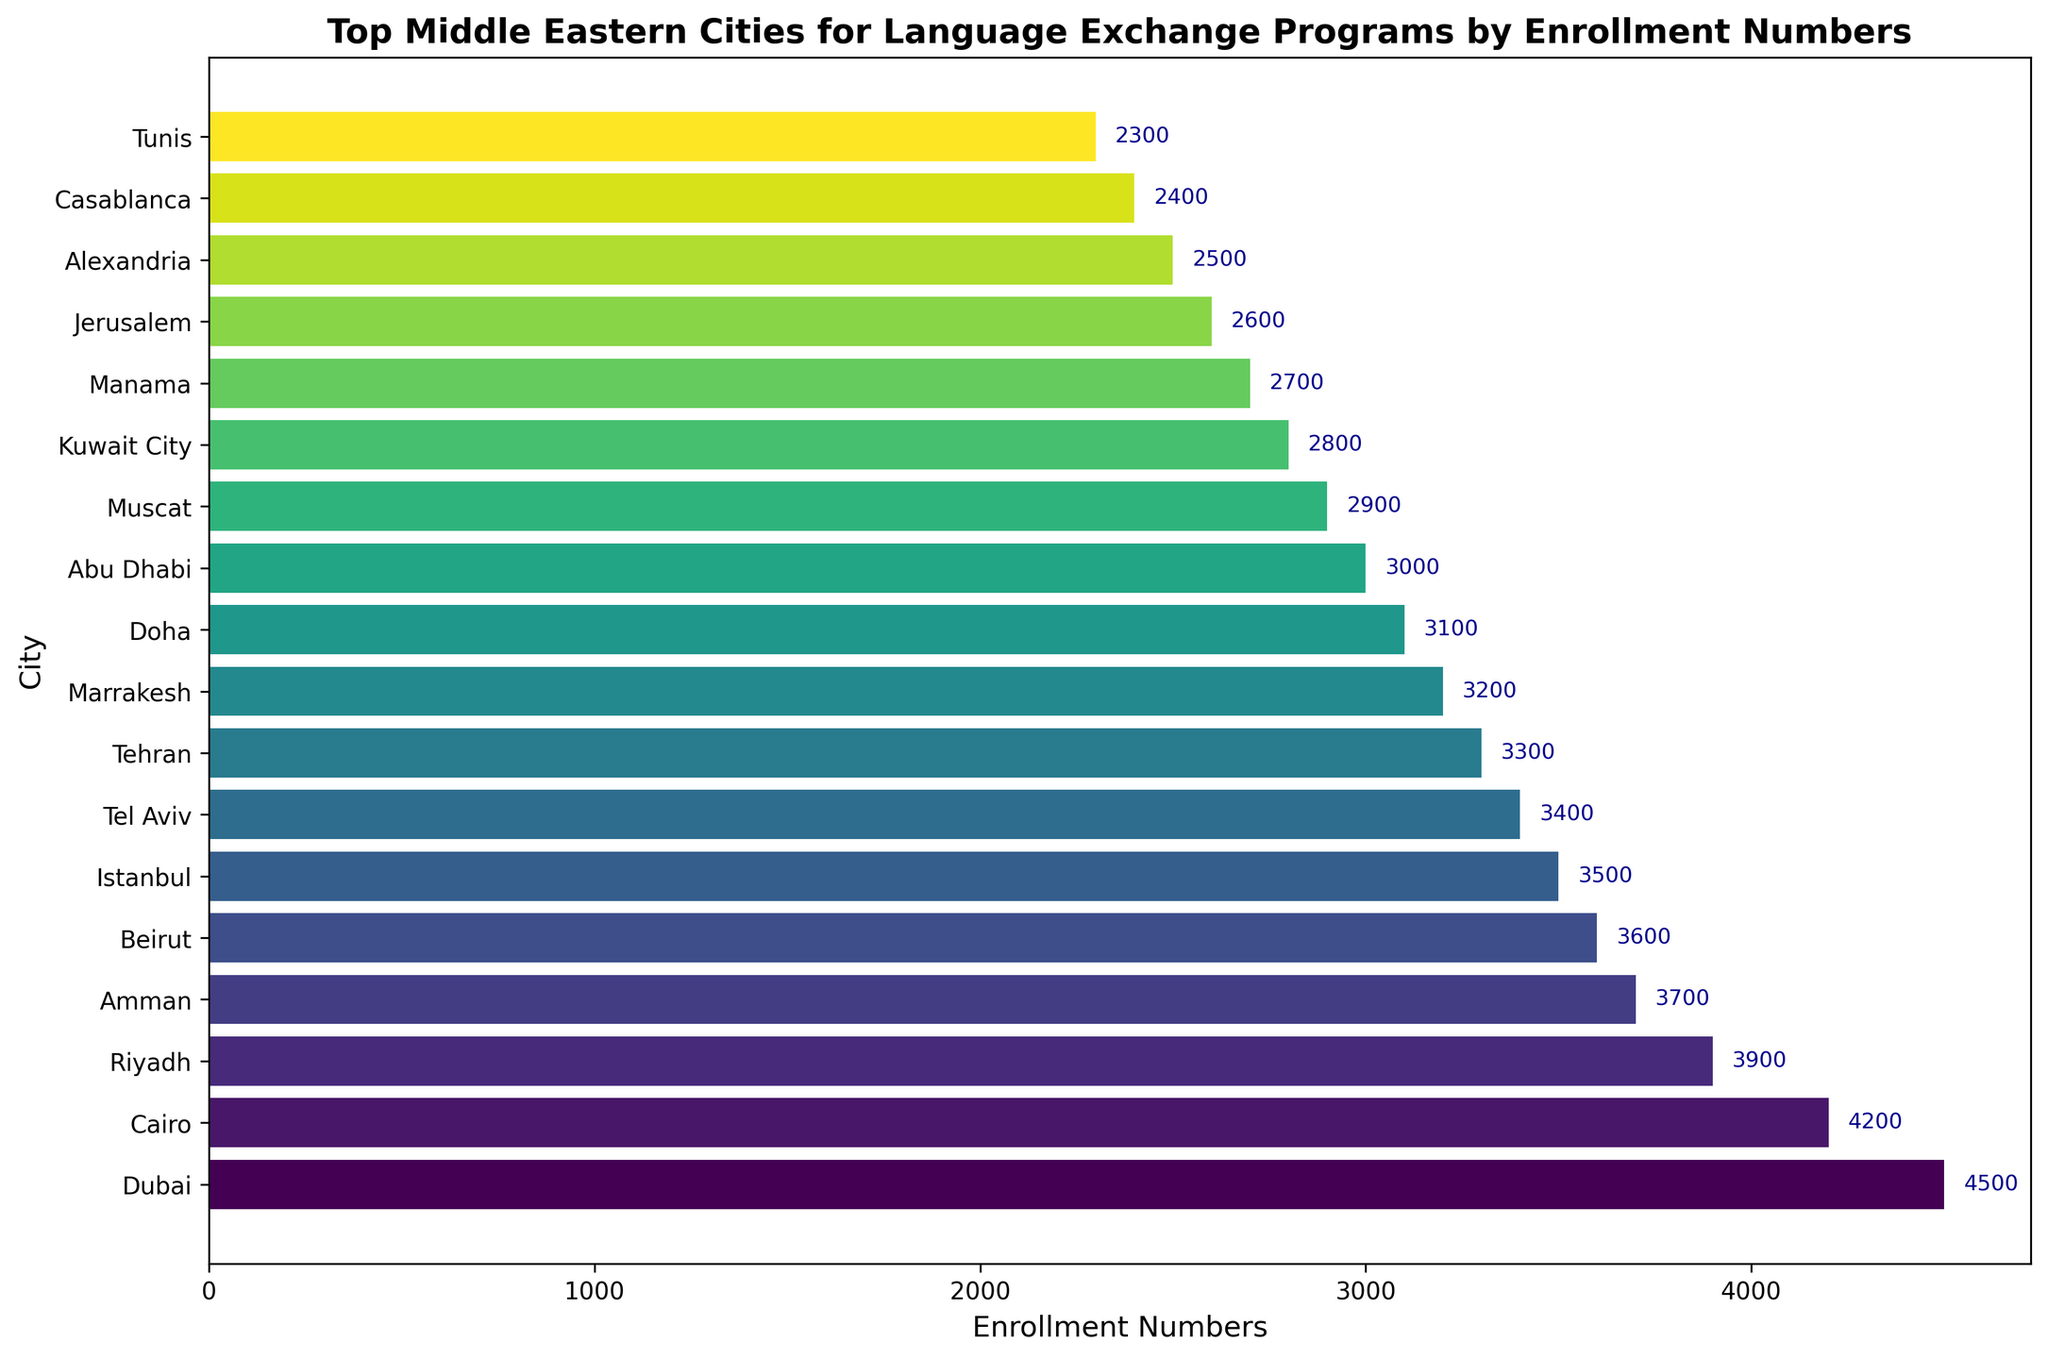what are the top three cities by enrollment numbers? The top three cities can be found by looking at the bars with the greatest lengths. These correspond to the highest enrollment numbers. The top three cities are Dubai, Cairo, and Riyadh.
Answer: Dubai, Cairo, Riyadh which city has higher enrollment numbers, Amman or Beirut? To find which city has higher enrollment numbers, compare the lengths of the bars for Amman and Beirut. The bar for Amman is longer than the bar for Beirut, which means Amman has higher enrollment numbers.
Answer: Amman how many cities have enrollment numbers less than 3000? To determine the number of cities with enrollment numbers less than 3000, count the bars with lengths representing numbers below 3000. These cities are Muscat, Kuwait City, Manama, Jerusalem, Alexandria, Casablanca, and Tunis. There are 7 cities in total.
Answer: 7 what is the range of enrollment numbers among the listed cities? The range is calculated by subtracting the enrollment number of the city with the smallest value from the city with the largest value. The highest enrollment number is Dubai with 4500, and the lowest is Tunis with 2300. The range is 4500 - 2300.
Answer: 2200 compare the total enrollment numbers of the top five and bottom five cities To compare, sum the enrollment numbers of the top five and bottom five cities. The top five cities are Dubai (4500), Cairo (4200), Riyadh (3900), Amman (3700), and Beirut (3600), totaling 19900. The bottom five cities are Manama (2700), Jerusalem (2600), Alexandria (2500), Casablanca (2400), and Tunis (2300), totaling 12500.
Answer: top 5: 19900, bottom 5: 12500 which city has the median enrollment number and what is it? To find the median, list the cities by enrollment numbers in ascending order and find the middle value. With 18 cities, the median is the average of the 9th and 10th values. These values are for Marrakesh (3200) and Doha (3100), so the median enrollment number is (3200 + 3100) / 2.
Answer: 3150 what is the difference in enrollment numbers between Cairo and Abu Dhabi? To find the difference, subtract Abu Dhabi's enrollment number from Cairo's. Cairo has 4200 enrollments and Abu Dhabi has 3000. The difference is 4200 - 3000.
Answer: 1200 